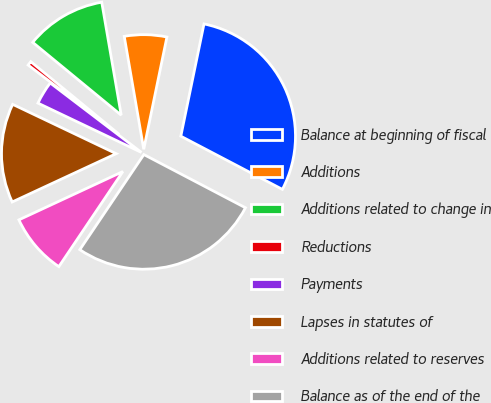Convert chart. <chart><loc_0><loc_0><loc_500><loc_500><pie_chart><fcel>Balance at beginning of fiscal<fcel>Additions<fcel>Additions related to change in<fcel>Reductions<fcel>Payments<fcel>Lapses in statutes of<fcel>Additions related to reserves<fcel>Balance as of the end of the<nl><fcel>29.43%<fcel>5.96%<fcel>11.32%<fcel>0.6%<fcel>3.28%<fcel>14.0%<fcel>8.64%<fcel>26.75%<nl></chart> 